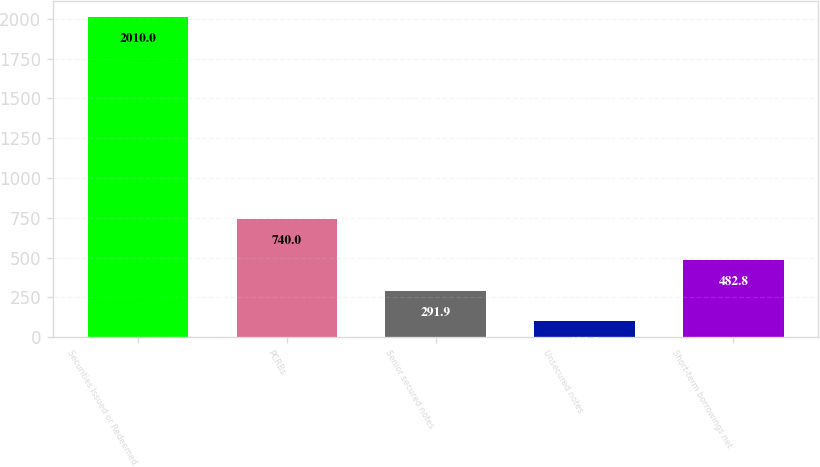Convert chart to OTSL. <chart><loc_0><loc_0><loc_500><loc_500><bar_chart><fcel>Securities Issued or Redeemed<fcel>PCRBs<fcel>Senior secured notes<fcel>Unsecured notes<fcel>Short-term borrowings net<nl><fcel>2010<fcel>740<fcel>291.9<fcel>101<fcel>482.8<nl></chart> 